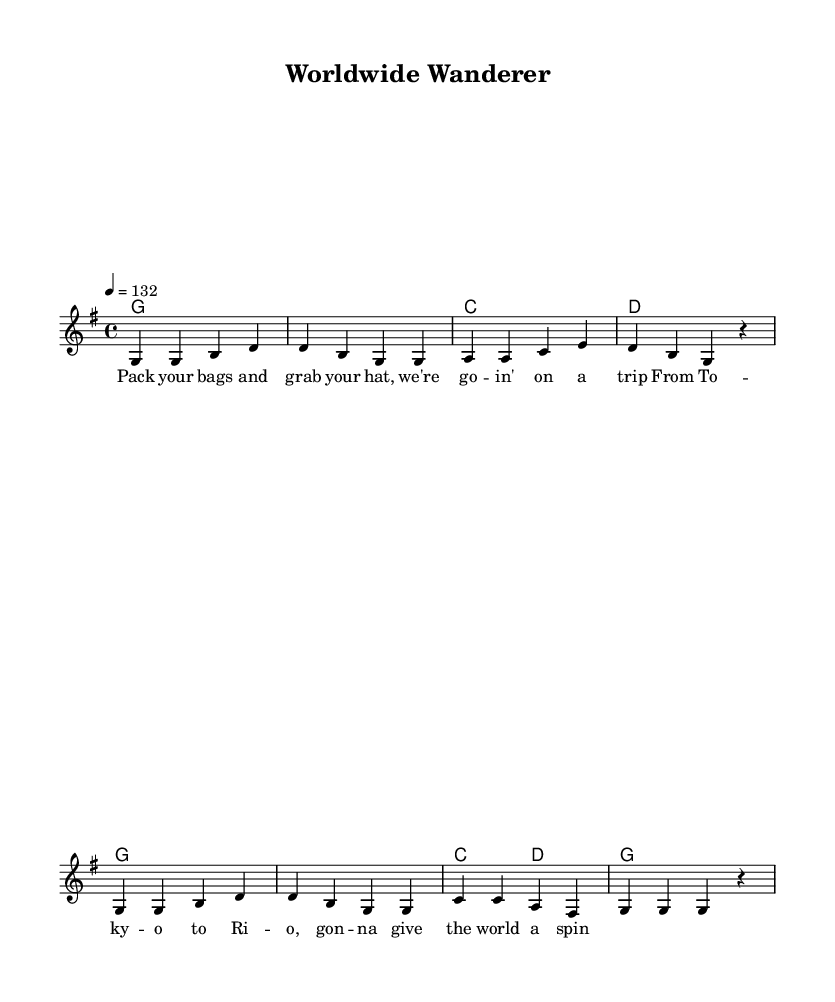What is the key signature of this music? The key signature shows one sharp, indicating that the music is in G major. This can be seen in the global music section where it says "\key g \major".
Answer: G major What is the time signature of this music? The time signature is found in the global section where it indicates the rhythm structure. Here, it is written as "\time 4/4", meaning there are four beats in each measure.
Answer: 4/4 What is the tempo marking for this music? The tempo marking is indicated in the global section, where it states "\tempo 4 = 132". This means the piece should be played at a speed of 132 beats per minute.
Answer: 132 How many measures are in the melody? By counting the individual lines of music within the melody section, we can see that there are eight measures in total, corresponding to the sequences of notes.
Answer: 8 What is the overall theme of the lyrics in the song? By reading the lyrics written in the verse section, it is clear that the theme revolves around traveling and exploring different places, suggesting a sense of adventure and discovery.
Answer: Traveling What instruments are likely involved in this music? The music notation indicates a lead melody and chord changes, suggesting the use of a lead instrument like a guitar or piano for the melody, accompanied by chords from harmony instruments.
Answer: Lead instrument and harmony In which countries does the song mention traveling? The lyrics mention traveling "From Tokyo to Rio," indicating that these two cities are the focal points in the song's narrative about exploring different cultures.
Answer: Tokyo and Rio 